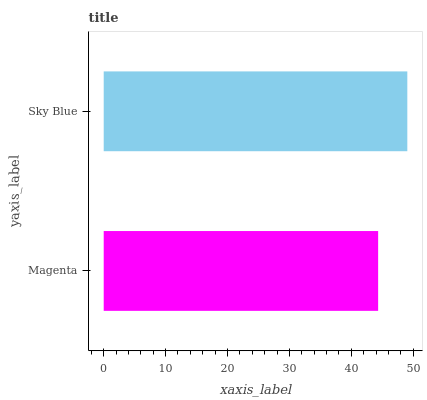Is Magenta the minimum?
Answer yes or no. Yes. Is Sky Blue the maximum?
Answer yes or no. Yes. Is Sky Blue the minimum?
Answer yes or no. No. Is Sky Blue greater than Magenta?
Answer yes or no. Yes. Is Magenta less than Sky Blue?
Answer yes or no. Yes. Is Magenta greater than Sky Blue?
Answer yes or no. No. Is Sky Blue less than Magenta?
Answer yes or no. No. Is Sky Blue the high median?
Answer yes or no. Yes. Is Magenta the low median?
Answer yes or no. Yes. Is Magenta the high median?
Answer yes or no. No. Is Sky Blue the low median?
Answer yes or no. No. 